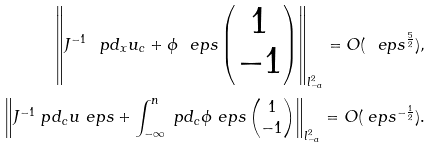Convert formula to latex. <formula><loc_0><loc_0><loc_500><loc_500>\left \| J ^ { - 1 } \ p d _ { x } { u } _ { c } + \phi _ { \ } e p s \begin{pmatrix} 1 \\ - 1 \end{pmatrix} \right \| _ { l ^ { 2 } _ { - a } } = O ( \ e p s ^ { \frac { 5 } { 2 } } ) , \\ \left \| J ^ { - 1 } \ p d _ { c } u _ { \ } e p s + \int _ { - \infty } ^ { n } \ p d _ { c } \phi _ { \ } e p s \begin{pmatrix} 1 \\ - 1 \end{pmatrix} \right \| _ { l ^ { 2 } _ { - a } } = O ( \ e p s ^ { - \frac { 1 } { 2 } } ) .</formula> 